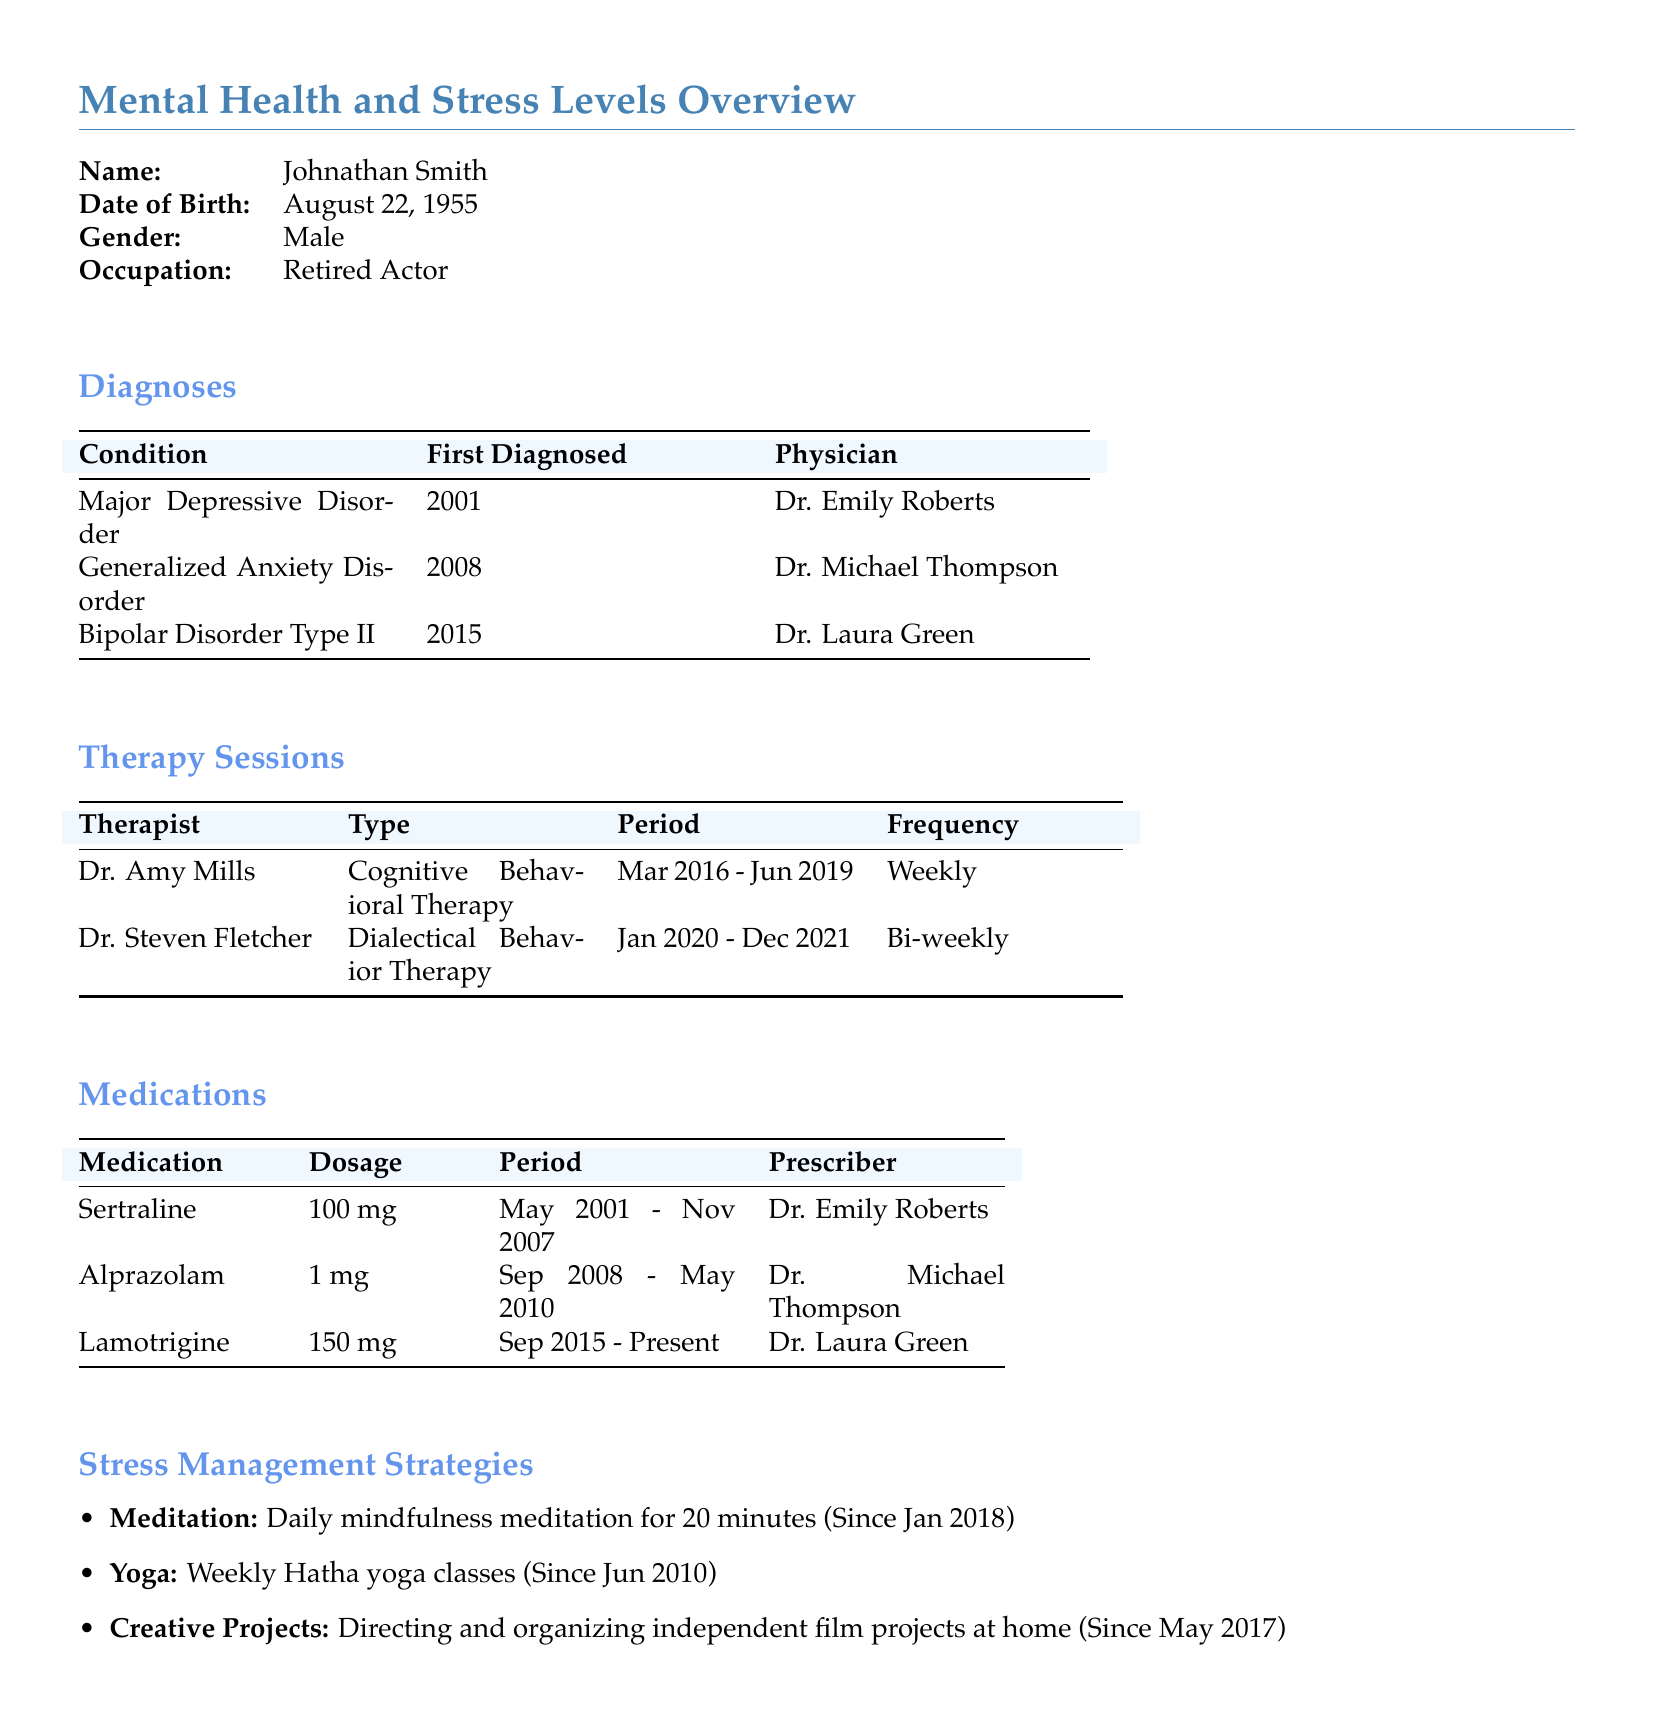What is the name of the patient? The name listed in the document is Johnathan Smith.
Answer: Johnathan Smith What is the first diagnosed condition? The first condition listed in the diagnoses section is Major Depressive Disorder.
Answer: Major Depressive Disorder Who was the prescriber for Alprazolam? The medication Alprazolam was prescribed by Dr. Michael Thompson.
Answer: Dr. Michael Thompson How long did Johnathan attend Cognitive Behavioral Therapy? The document states the period for this therapy was from March 2016 to June 2019.
Answer: Mar 2016 - Jun 2019 What is the dosage of Lamotrigine? The dosage mentioned for Lamotrigine is 150 mg.
Answer: 150 mg Which stress management strategy has been utilized since January 2018? The stress management strategy mentioned is daily mindfulness meditation.
Answer: Daily mindfulness meditation How many different therapists did Johnathan see? There are two different therapists listed in the document.
Answer: Two What type of therapy did Dr. Steven Fletcher provide? The type of therapy provided by Dr. Steven Fletcher is Dialectical Behavior Therapy.
Answer: Dialectical Behavior Therapy When was Generalized Anxiety Disorder first diagnosed? Generalized Anxiety Disorder was first diagnosed in 2008.
Answer: 2008 